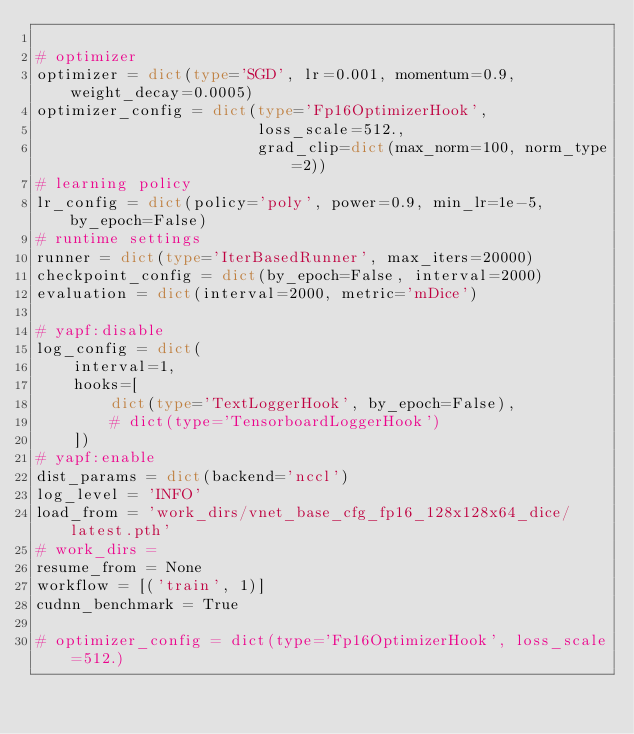<code> <loc_0><loc_0><loc_500><loc_500><_Python_>
# optimizer
optimizer = dict(type='SGD', lr=0.001, momentum=0.9, weight_decay=0.0005)
optimizer_config = dict(type='Fp16OptimizerHook',
                        loss_scale=512.,
                        grad_clip=dict(max_norm=100, norm_type=2))
# learning policy
lr_config = dict(policy='poly', power=0.9, min_lr=1e-5, by_epoch=False)
# runtime settings
runner = dict(type='IterBasedRunner', max_iters=20000)
checkpoint_config = dict(by_epoch=False, interval=2000)
evaluation = dict(interval=2000, metric='mDice')

# yapf:disable
log_config = dict(
    interval=1,
    hooks=[
        dict(type='TextLoggerHook', by_epoch=False),
        # dict(type='TensorboardLoggerHook')
    ])
# yapf:enable
dist_params = dict(backend='nccl')
log_level = 'INFO'
load_from = 'work_dirs/vnet_base_cfg_fp16_128x128x64_dice/latest.pth'
# work_dirs =
resume_from = None
workflow = [('train', 1)]
cudnn_benchmark = True

# optimizer_config = dict(type='Fp16OptimizerHook', loss_scale=512.)</code> 